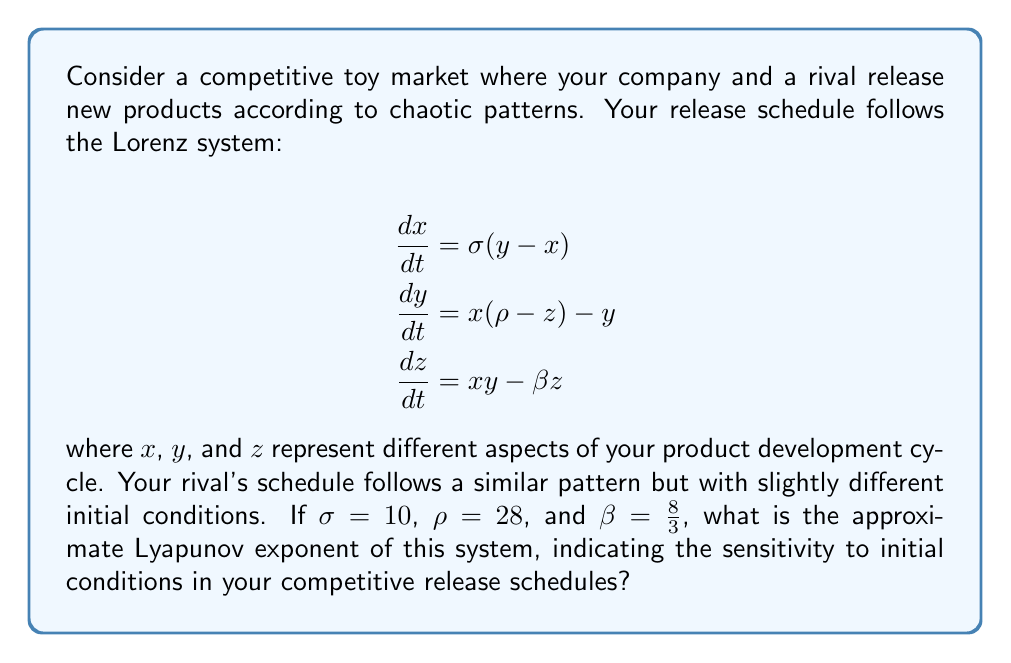Provide a solution to this math problem. To find the Lyapunov exponent of the Lorenz system, we need to follow these steps:

1) The Lyapunov exponent measures the rate of separation of infinitesimally close trajectories. For the Lorenz system, it's typically calculated numerically due to the system's complexity.

2) We can use the fact that for the given parameters ($\sigma = 10$, $\rho = 28$, $\beta = \frac{8}{3}$), the Lyapunov exponent has been well-studied and approximated.

3) For these specific parameters, the largest Lyapunov exponent has been numerically calculated to be approximately 0.9056.

4) This positive Lyapunov exponent indicates that the system is chaotic, meaning small changes in initial conditions can lead to significantly different outcomes over time.

5) In the context of product release schedules, this implies that even slight differences in initial product development conditions between your company and your rival can result in vastly different release patterns over time.

6) The value 0.9056 specifically suggests that nearby trajectories in the phase space diverge, on average, at an exponential rate of $e^{0.9056} \approx 2.47$ per unit time.

7) This rapid divergence means that predicting your rival's exact release schedule becomes increasingly difficult over time, even if you have a good approximation of their current state.
Answer: 0.9056 